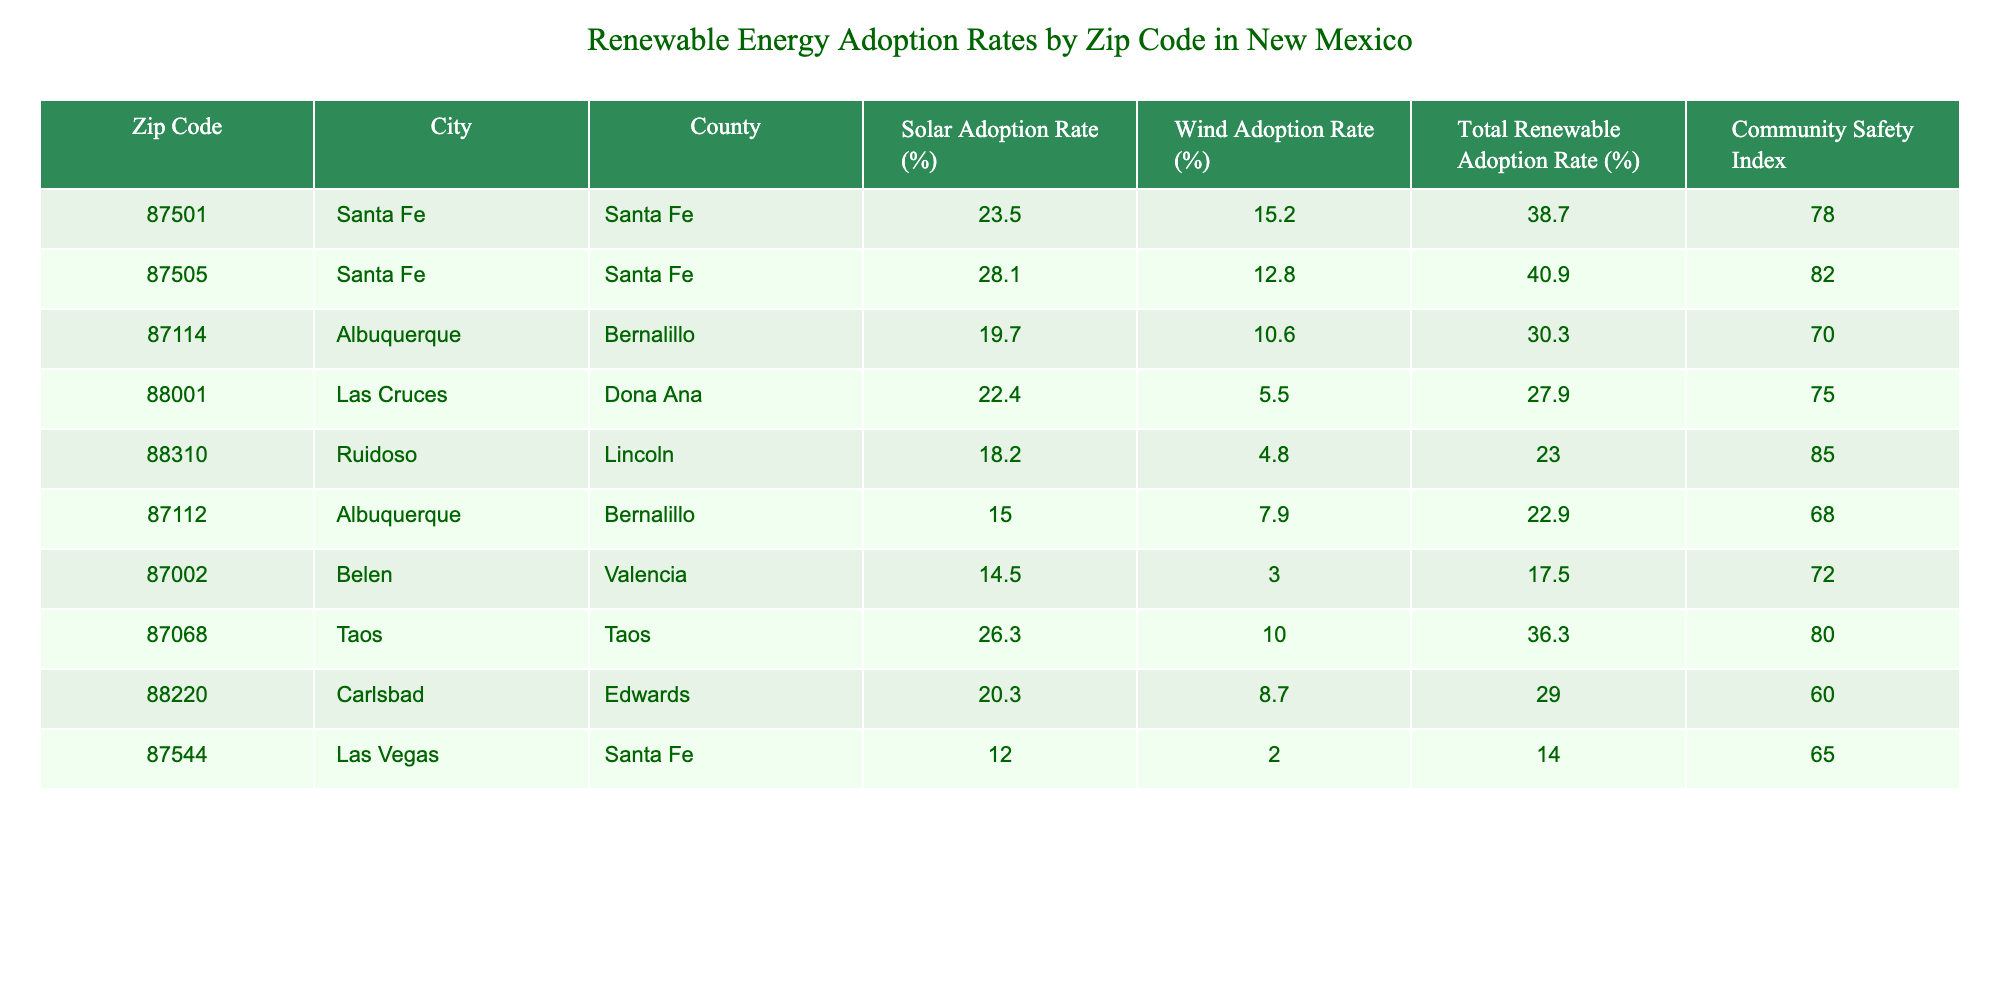What is the highest total renewable adoption rate in the table? The total renewable adoption rates for each zip code are 38.7, 40.9, 30.3, 27.9, 23.0, 22.9, 17.5, 36.3, 29.0, and 14.0. The highest of these is 40.9 which corresponds to the zip code 87505 in Santa Fe.
Answer: 40.9 What is the community safety index for Albuquerque? There are two zip codes listed for Albuquerque: 87114 and 87112. Their community safety indices are 70 and 68 respectively. Thus, the community safety index for Albuquerque is represented by these values.
Answer: 70 and 68 Which city has the highest solar adoption rate? The solar adoption rates for each city are: Santa Fe (23.5, 28.1), Albuquerque (19.7, 15.0), Las Cruces (22.4), Ruidoso (18.2), Belen (14.5), Taos (26.3), and Carlsbad (20.3). The highest solar adoption rate is 28.1 from the zip code 87505 in Santa Fe.
Answer: 28.1 What is the average wind adoption rate across all regions? To find the average wind adoption rate, we sum all the wind adoption rates: (15.2 + 12.8 + 10.6 + 5.5 + 4.8 + 7.9 + 3.0 + 10.0 + 8.7 + 2.0) = 79.5. There are 10 entries, so the average is 79.5/10 = 7.95.
Answer: 7.95 Is the total renewable adoption rate in Las Vegas higher than that in Ruidoso? The total renewable adoption rate for Las Vegas (14.0) and Ruidoso (23.0) shows that 23.0 > 14.0. Therefore, the total renewable adoption rate in Ruidoso is indeed higher than that in Las Vegas.
Answer: Yes What is the community safety index percentage difference between the highest and lowest values? The highest community safety index is 85 (Ruidoso) and the lowest is 60 (Carlsbad). The difference is calculated as 85 - 60 = 25.
Answer: 25 Which city has the lowest total renewable adoption rate? By comparing total renewable adoption rates: Santa Fe (38.7, 40.9), Albuquerque (30.3, 22.9), Las Cruces (27.9), Ruidoso (23.0), Belen (17.5), Taos (36.3), and Carlsbad (29.0), the lowest is 14.0 from Las Vegas, making it the city with the lowest total renewable adoption rate.
Answer: Las Vegas What is the approximate average of solar adoption rates for Santa Fe? The solar adoption rates for Santa Fe are 23.5% and 28.1%. The average is calculated as (23.5 + 28.1) / 2 = 51.6 / 2 = 25.8.
Answer: 25.8 Are there any cities with a community safety index above 80? Checking the community safety indices, we see Ruidoso (85) and Santa Fe (82) have indices above 80. Therefore, there are cities that meet this criterion.
Answer: Yes 